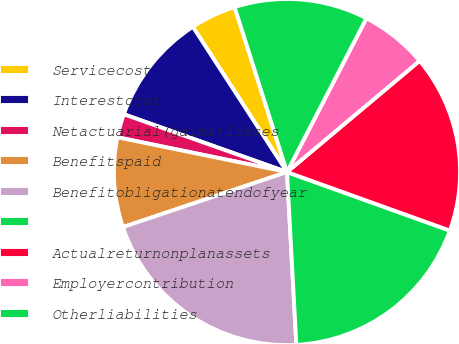<chart> <loc_0><loc_0><loc_500><loc_500><pie_chart><fcel>Servicecost<fcel>Interestcost<fcel>Netactuarial(gains)losses<fcel>Benefitspaid<fcel>Benefitobligationatendofyear<fcel>Unnamed: 5<fcel>Actualreturnonplanassets<fcel>Employercontribution<fcel>Otherliabilities<nl><fcel>4.26%<fcel>10.43%<fcel>2.2%<fcel>8.37%<fcel>20.71%<fcel>18.65%<fcel>16.6%<fcel>6.31%<fcel>12.48%<nl></chart> 